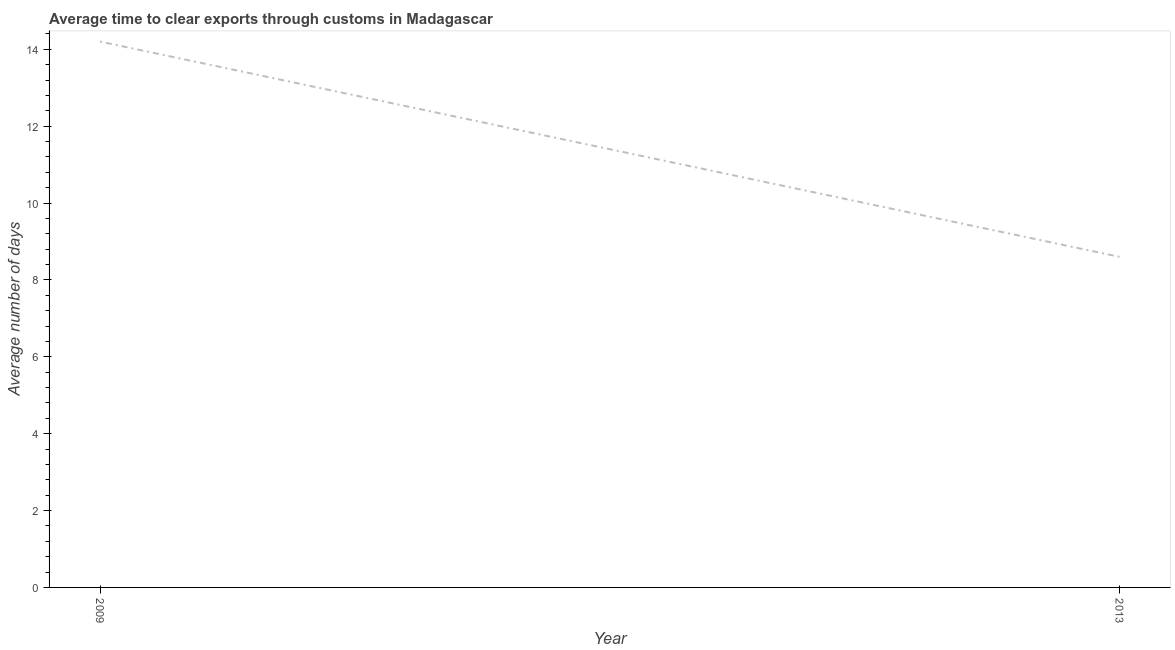Across all years, what is the maximum time to clear exports through customs?
Provide a succinct answer. 14.2. Across all years, what is the minimum time to clear exports through customs?
Offer a very short reply. 8.6. In which year was the time to clear exports through customs maximum?
Offer a terse response. 2009. What is the sum of the time to clear exports through customs?
Keep it short and to the point. 22.8. What is the difference between the time to clear exports through customs in 2009 and 2013?
Provide a succinct answer. 5.6. What is the average time to clear exports through customs per year?
Keep it short and to the point. 11.4. What is the median time to clear exports through customs?
Offer a very short reply. 11.4. In how many years, is the time to clear exports through customs greater than 10.4 days?
Provide a succinct answer. 1. What is the ratio of the time to clear exports through customs in 2009 to that in 2013?
Your answer should be very brief. 1.65. Does the time to clear exports through customs monotonically increase over the years?
Offer a terse response. No. How many lines are there?
Your answer should be compact. 1. Are the values on the major ticks of Y-axis written in scientific E-notation?
Provide a succinct answer. No. Does the graph contain any zero values?
Your answer should be very brief. No. Does the graph contain grids?
Your response must be concise. No. What is the title of the graph?
Your response must be concise. Average time to clear exports through customs in Madagascar. What is the label or title of the X-axis?
Ensure brevity in your answer.  Year. What is the label or title of the Y-axis?
Provide a succinct answer. Average number of days. What is the Average number of days in 2009?
Ensure brevity in your answer.  14.2. What is the difference between the Average number of days in 2009 and 2013?
Give a very brief answer. 5.6. What is the ratio of the Average number of days in 2009 to that in 2013?
Make the answer very short. 1.65. 